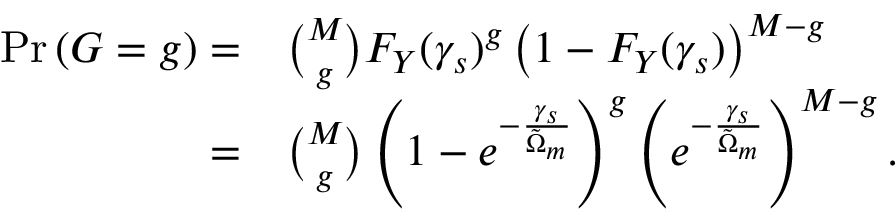Convert formula to latex. <formula><loc_0><loc_0><loc_500><loc_500>\begin{array} { r l } { P r \left ( G = g \right ) = } & { \binom { M } { g } F _ { Y } ( \gamma _ { s } ) ^ { g } \left ( 1 - F _ { Y } ( \gamma _ { s } ) \right ) ^ { M - g } } \\ { = } & { \binom { M } { g } \left ( 1 - e ^ { - \frac { \gamma _ { s } } { \tilde { \Omega } _ { m } } } \right ) ^ { g } \left ( e ^ { - \frac { \gamma _ { s } } { \tilde { \Omega } _ { m } } } \right ) ^ { M - g } . } \end{array}</formula> 